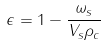Convert formula to latex. <formula><loc_0><loc_0><loc_500><loc_500>\epsilon = 1 - \frac { \omega _ { s } } { V _ { s } \rho _ { c } }</formula> 